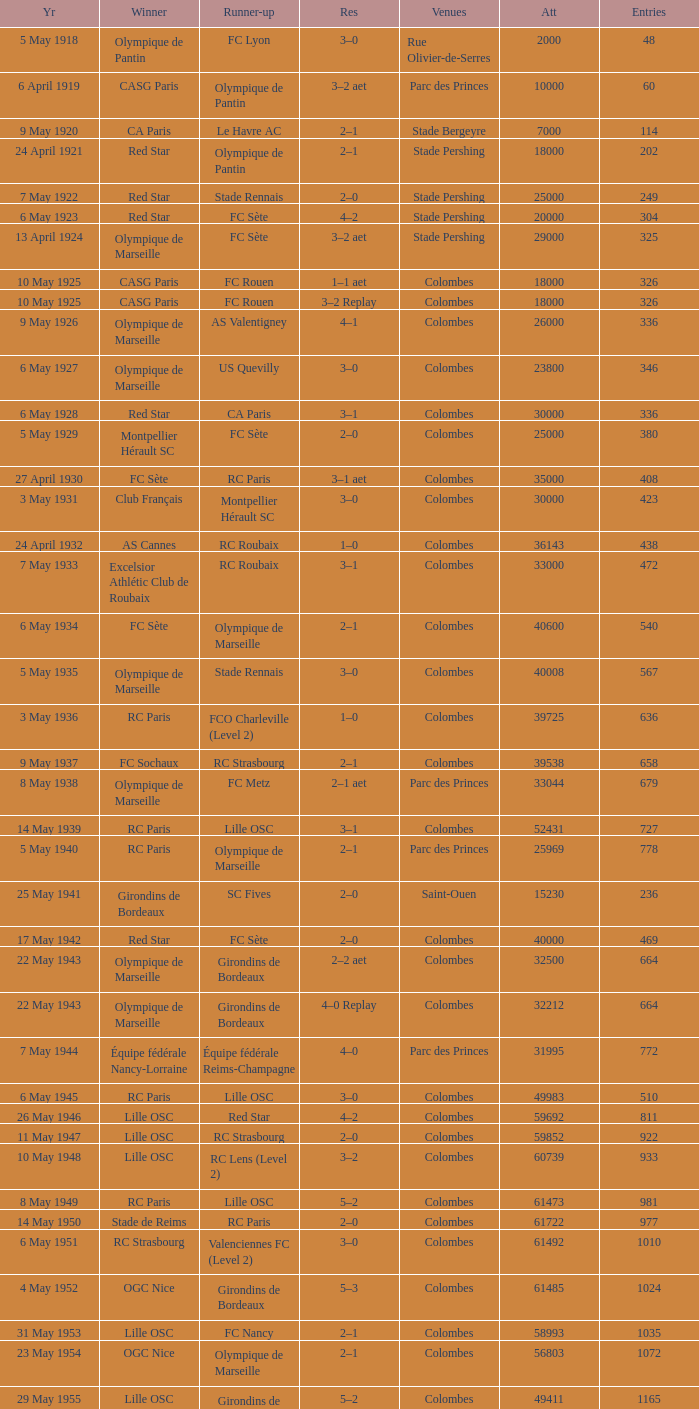What is the fewest recorded entrants against paris saint-germain? 6394.0. 